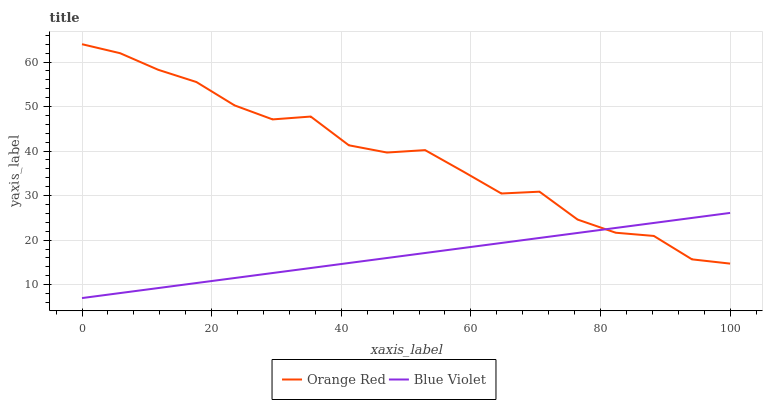Does Blue Violet have the maximum area under the curve?
Answer yes or no. No. Is Blue Violet the roughest?
Answer yes or no. No. Does Blue Violet have the highest value?
Answer yes or no. No. 